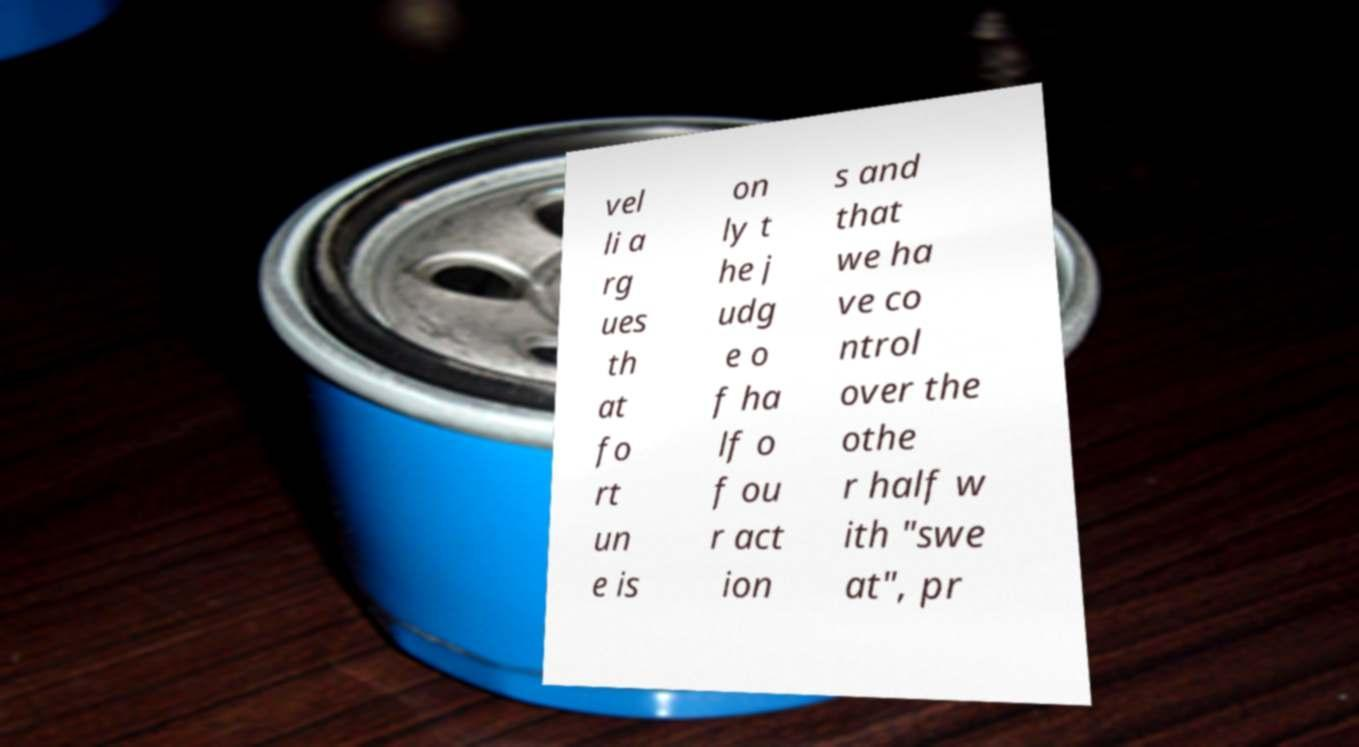Could you assist in decoding the text presented in this image and type it out clearly? vel li a rg ues th at fo rt un e is on ly t he j udg e o f ha lf o f ou r act ion s and that we ha ve co ntrol over the othe r half w ith "swe at", pr 